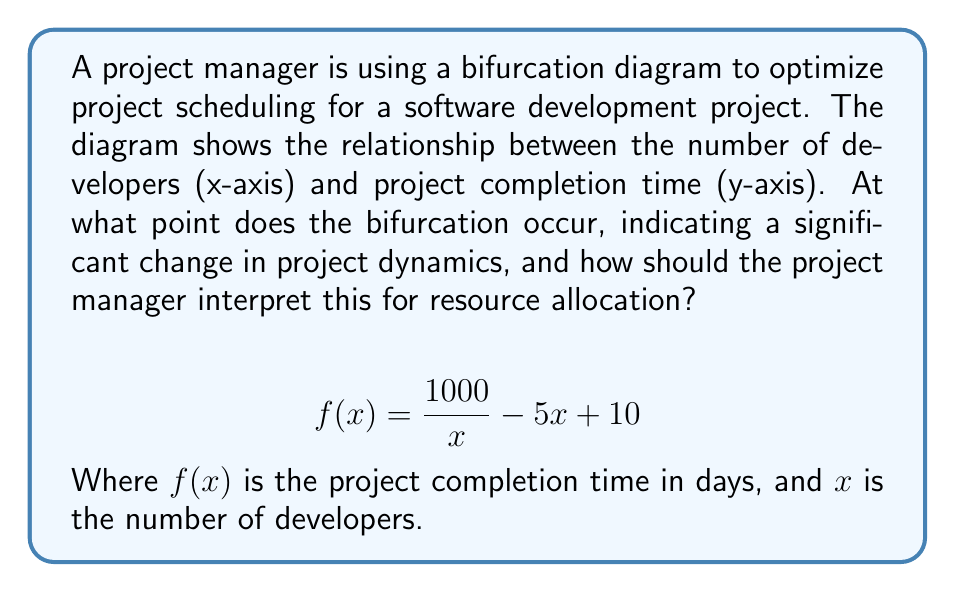Can you answer this question? To find the bifurcation point, we need to analyze the function for critical points:

1. Take the derivative of $f(x)$:
   $$f'(x) = -\frac{1000}{x^2} - 5$$

2. Set $f'(x) = 0$ and solve for $x$:
   $$-\frac{1000}{x^2} - 5 = 0$$
   $$-\frac{1000}{x^2} = 5$$
   $$\frac{1000}{x^2} = 5$$
   $$x^2 = 200$$
   $$x = \sqrt{200} \approx 14.14$$

3. The bifurcation occurs at approximately 14 developers.

4. Interpret the result:
   - Below 14 developers: Adding more developers significantly reduces project time.
   - Above 14 developers: Adding more developers has diminishing returns and may increase project time due to communication overhead.

5. For resource allocation:
   - Optimal team size is around 14 developers.
   - Increasing beyond this may not improve efficiency and could lead to increased costs.
   - Decreasing below this point may significantly extend the project timeline.
Answer: Bifurcation at 14 developers; optimal team size for efficient resource allocation. 